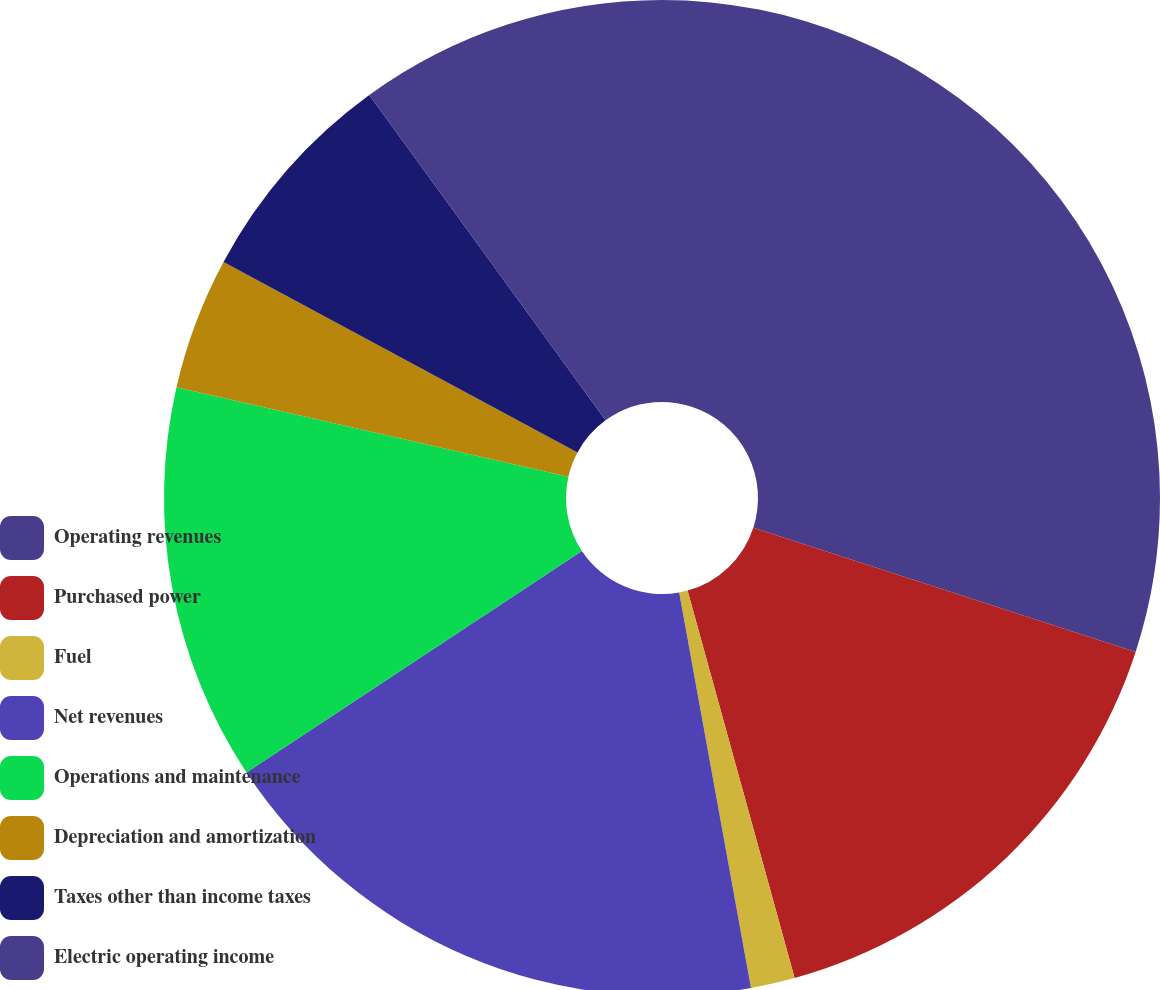Convert chart to OTSL. <chart><loc_0><loc_0><loc_500><loc_500><pie_chart><fcel>Operating revenues<fcel>Purchased power<fcel>Fuel<fcel>Net revenues<fcel>Operations and maintenance<fcel>Depreciation and amortization<fcel>Taxes other than income taxes<fcel>Electric operating income<nl><fcel>30.0%<fcel>15.71%<fcel>1.43%<fcel>18.57%<fcel>12.86%<fcel>4.29%<fcel>7.14%<fcel>10.0%<nl></chart> 